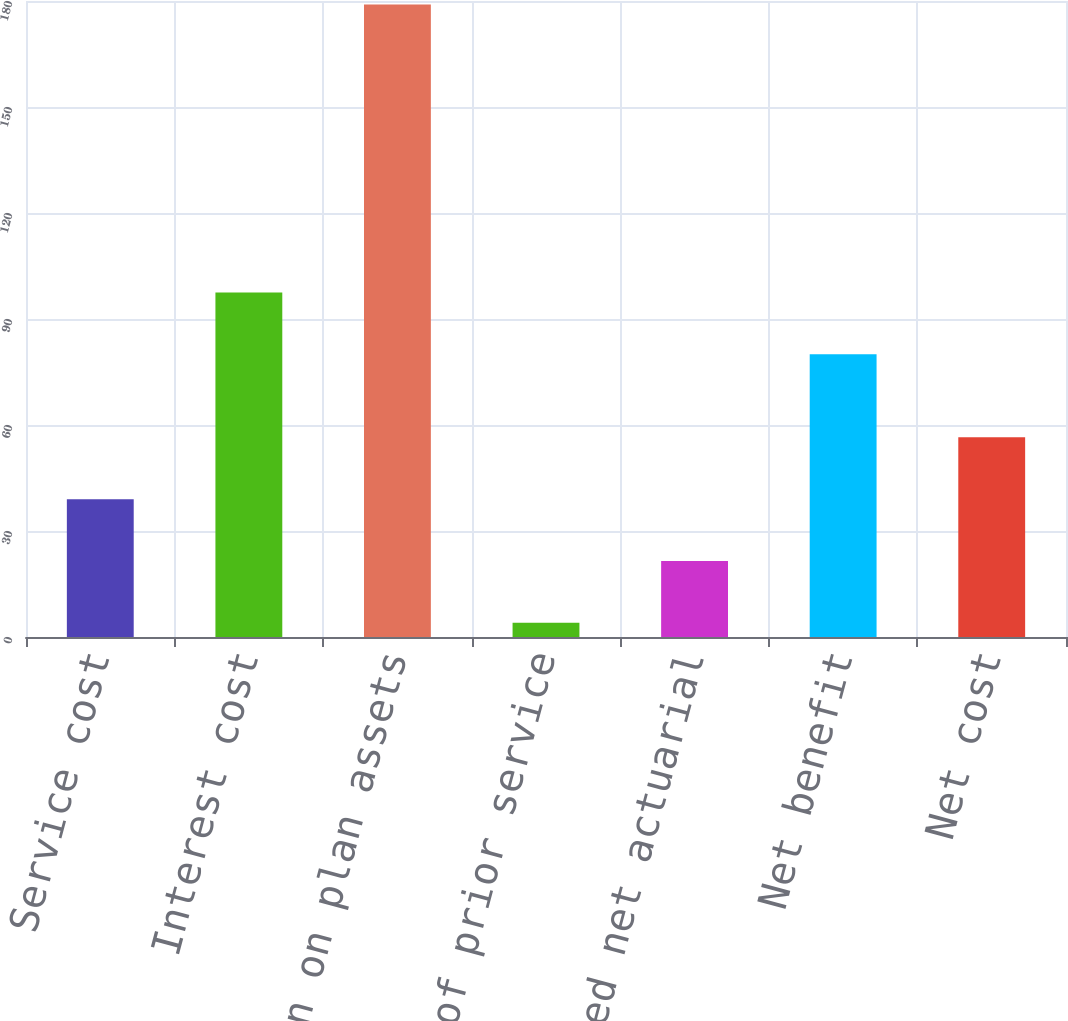<chart> <loc_0><loc_0><loc_500><loc_500><bar_chart><fcel>Service cost<fcel>Interest cost<fcel>Expected return on plan assets<fcel>Amortization of prior service<fcel>Recognized net actuarial<fcel>Net benefit<fcel>Net cost<nl><fcel>39<fcel>97.5<fcel>179<fcel>4<fcel>21.5<fcel>80<fcel>56.5<nl></chart> 